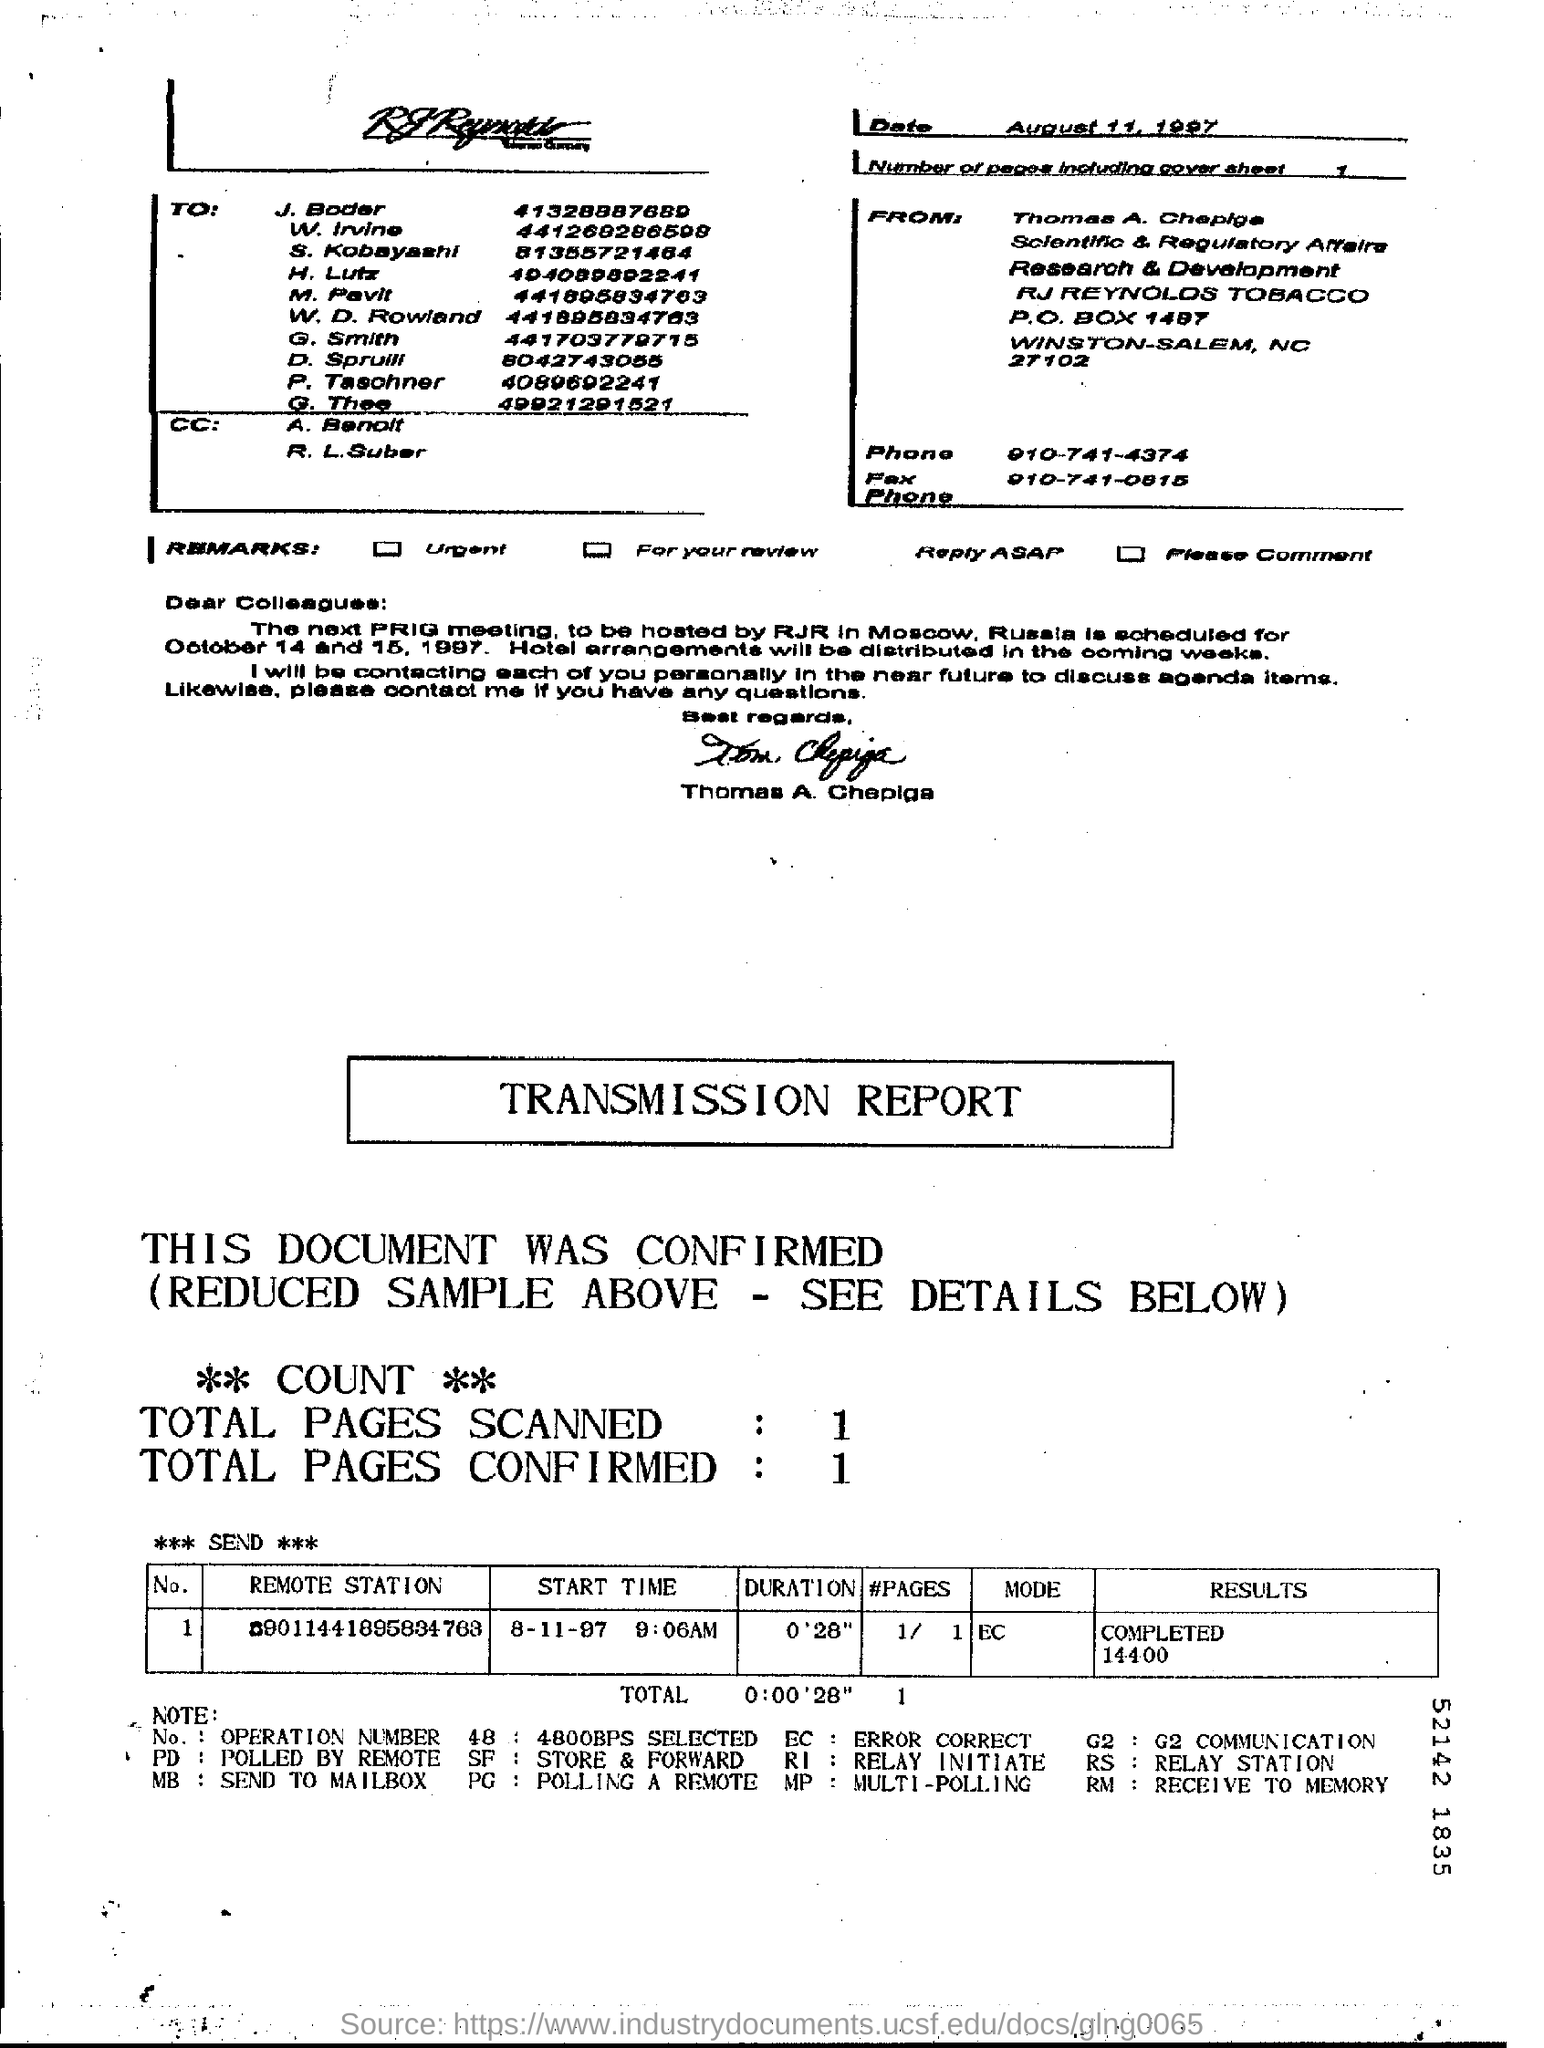Specify some key components in this picture. The total number of pages that have been confirmed is 1.. What is the duration? It is 0'28". On August 8th, 1997, at 9:06 AM, the Start Time was recorded as 'What is the "Start Time"? 8-11-97 9:06AM..'. 